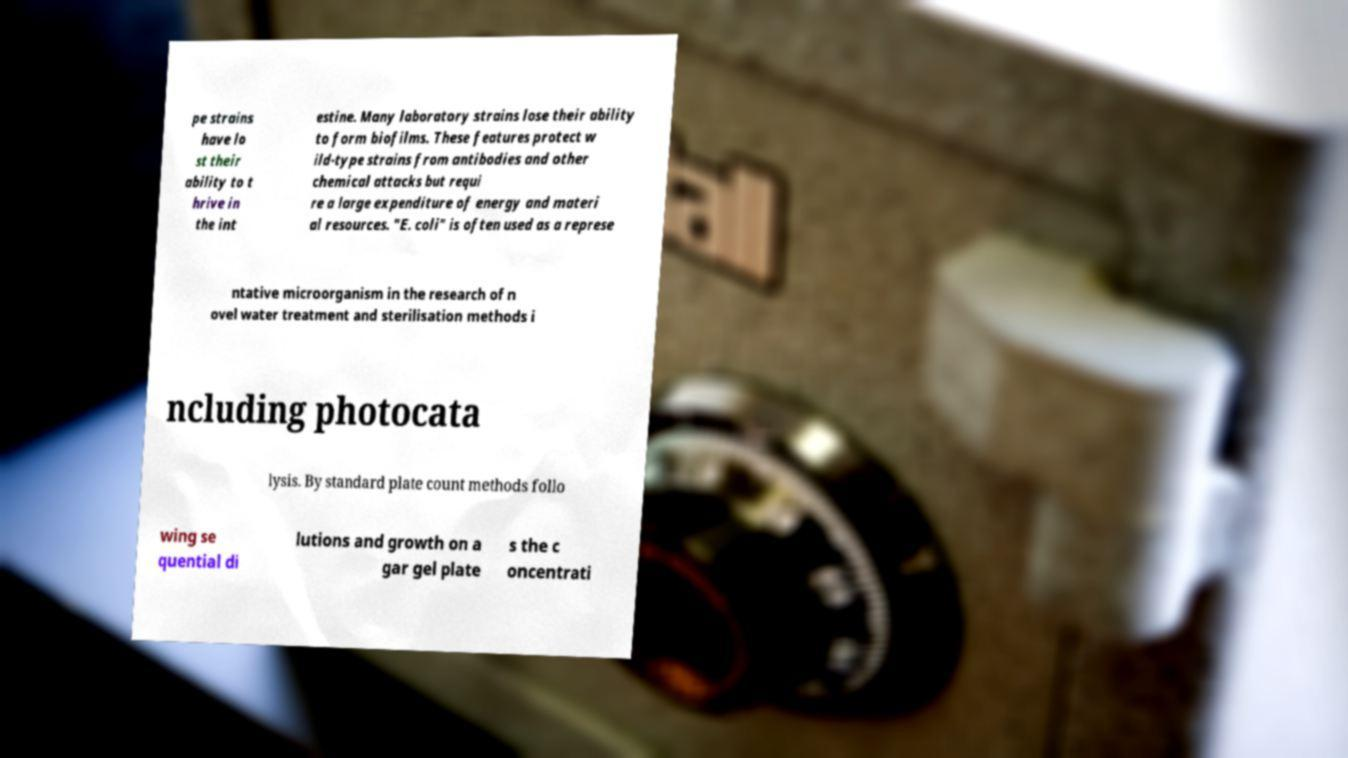Could you extract and type out the text from this image? pe strains have lo st their ability to t hrive in the int estine. Many laboratory strains lose their ability to form biofilms. These features protect w ild-type strains from antibodies and other chemical attacks but requi re a large expenditure of energy and materi al resources. "E. coli" is often used as a represe ntative microorganism in the research of n ovel water treatment and sterilisation methods i ncluding photocata lysis. By standard plate count methods follo wing se quential di lutions and growth on a gar gel plate s the c oncentrati 